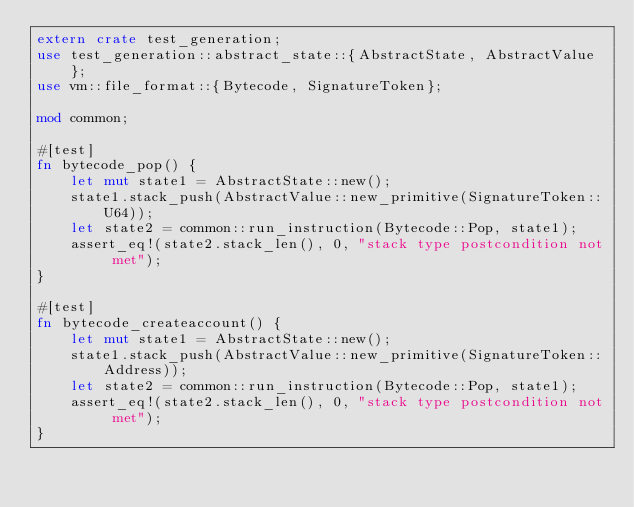<code> <loc_0><loc_0><loc_500><loc_500><_Rust_>extern crate test_generation;
use test_generation::abstract_state::{AbstractState, AbstractValue};
use vm::file_format::{Bytecode, SignatureToken};

mod common;

#[test]
fn bytecode_pop() {
    let mut state1 = AbstractState::new();
    state1.stack_push(AbstractValue::new_primitive(SignatureToken::U64));
    let state2 = common::run_instruction(Bytecode::Pop, state1);
    assert_eq!(state2.stack_len(), 0, "stack type postcondition not met");
}

#[test]
fn bytecode_createaccount() {
    let mut state1 = AbstractState::new();
    state1.stack_push(AbstractValue::new_primitive(SignatureToken::Address));
    let state2 = common::run_instruction(Bytecode::Pop, state1);
    assert_eq!(state2.stack_len(), 0, "stack type postcondition not met");
}
</code> 